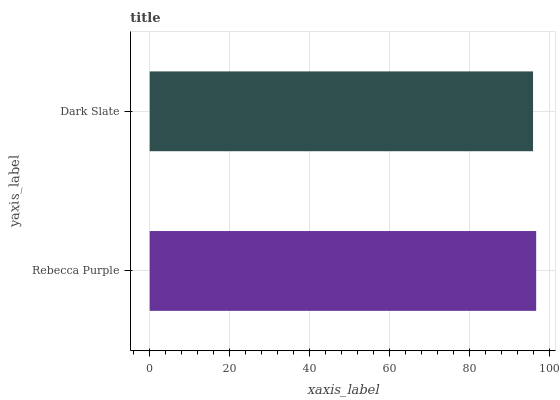Is Dark Slate the minimum?
Answer yes or no. Yes. Is Rebecca Purple the maximum?
Answer yes or no. Yes. Is Dark Slate the maximum?
Answer yes or no. No. Is Rebecca Purple greater than Dark Slate?
Answer yes or no. Yes. Is Dark Slate less than Rebecca Purple?
Answer yes or no. Yes. Is Dark Slate greater than Rebecca Purple?
Answer yes or no. No. Is Rebecca Purple less than Dark Slate?
Answer yes or no. No. Is Rebecca Purple the high median?
Answer yes or no. Yes. Is Dark Slate the low median?
Answer yes or no. Yes. Is Dark Slate the high median?
Answer yes or no. No. Is Rebecca Purple the low median?
Answer yes or no. No. 